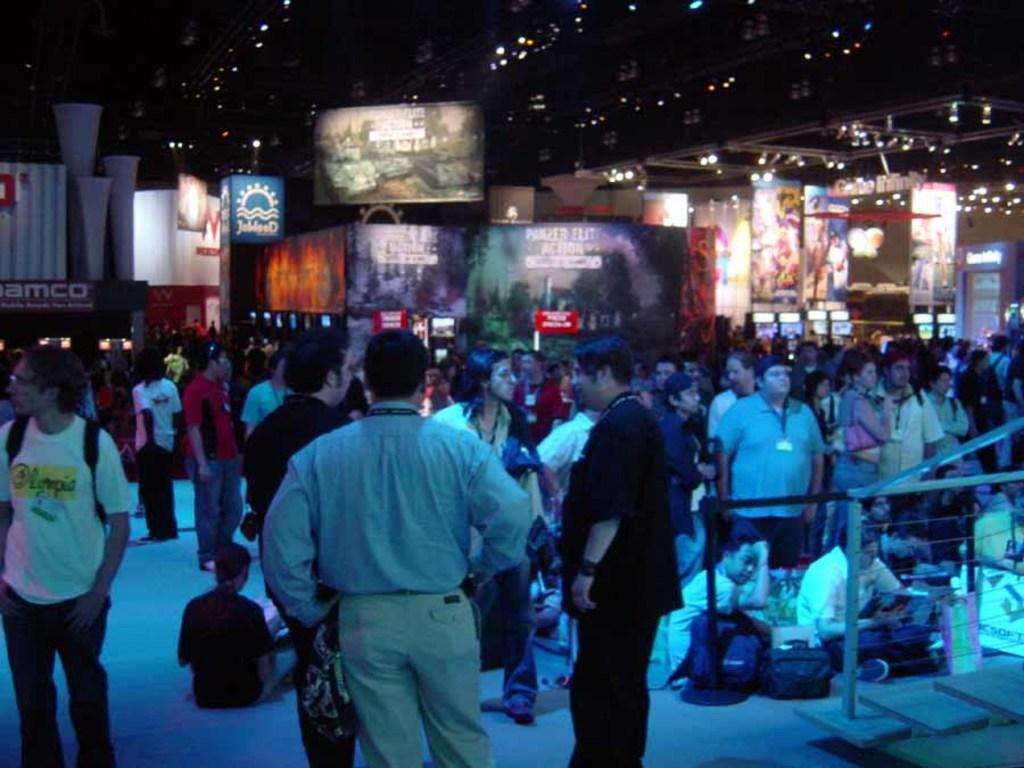How many people are in the image? There is a group of people in the image, but the exact number is not specified. What are the people in the image doing? Some people are sitting, while others are standing. Where are the people located in the image? The people are on the ground. What can be seen in the background of the image? There are banners, lights, and other unspecified objects in the background of the image. What type of angle is being used to take the picture of the ducks in the image? There are no ducks present in the image, so the question about the angle used to take their picture is not applicable. 